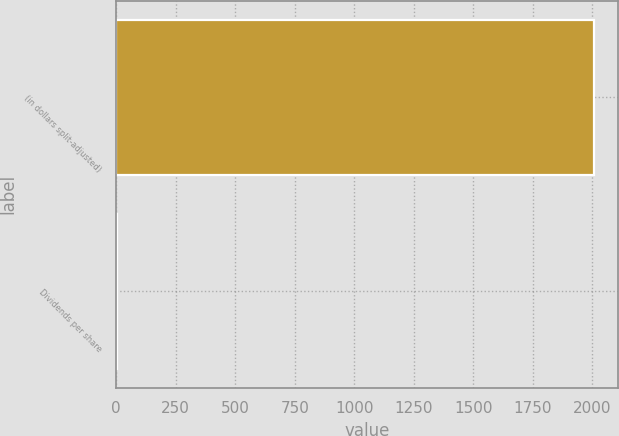Convert chart. <chart><loc_0><loc_0><loc_500><loc_500><bar_chart><fcel>(in dollars split-adjusted)<fcel>Dividends per share<nl><fcel>2007<fcel>1.28<nl></chart> 